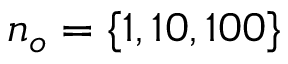<formula> <loc_0><loc_0><loc_500><loc_500>n _ { o } = \{ 1 , 1 0 , 1 0 0 \}</formula> 